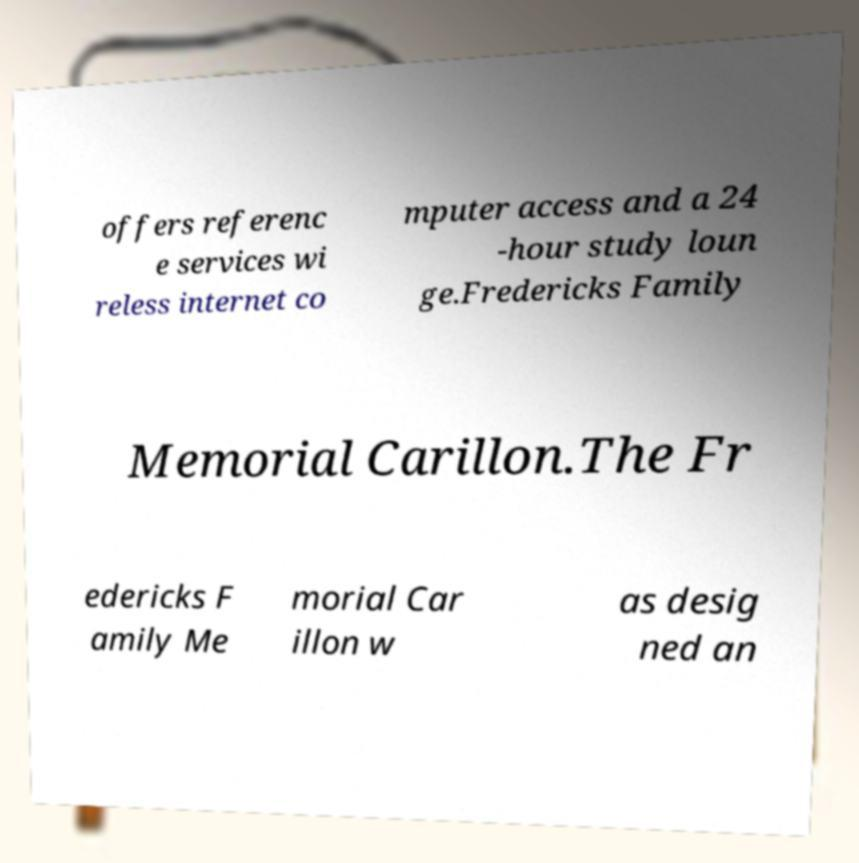Could you extract and type out the text from this image? offers referenc e services wi reless internet co mputer access and a 24 -hour study loun ge.Fredericks Family Memorial Carillon.The Fr edericks F amily Me morial Car illon w as desig ned an 